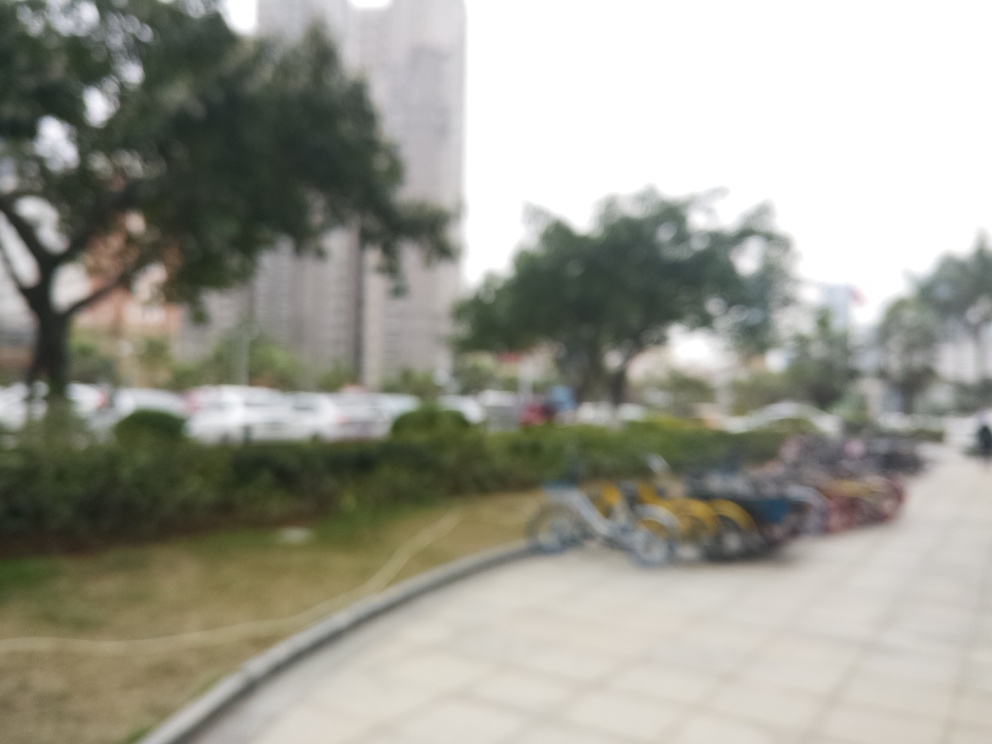Can you identify any specific objects or features in this photo despite the blurriness? Although the blurriness limits the ability to make out specific details, we can still perceive the outlines of trees, some parked vehicles, and a row of bicycles. There also appears to be a pathway curving through a grassy area, leading towards buildings in the distance. 